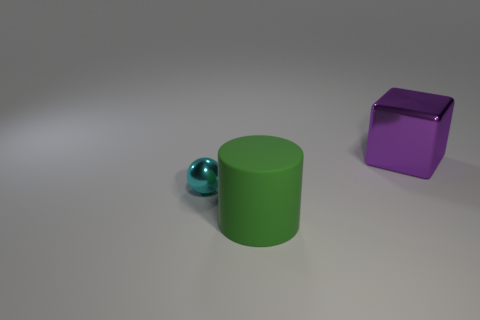If these objects were to be used in a scene, what sort of setting might they be a part of? Given their simple shapes and unblemished surfaces, these objects could be part of a minimalist or modern setting. They might be props in a conceptual art piece or used in a graphic design project to study form and color contrast. Alternatively, they could be educational models for teaching geometry and color theory. 